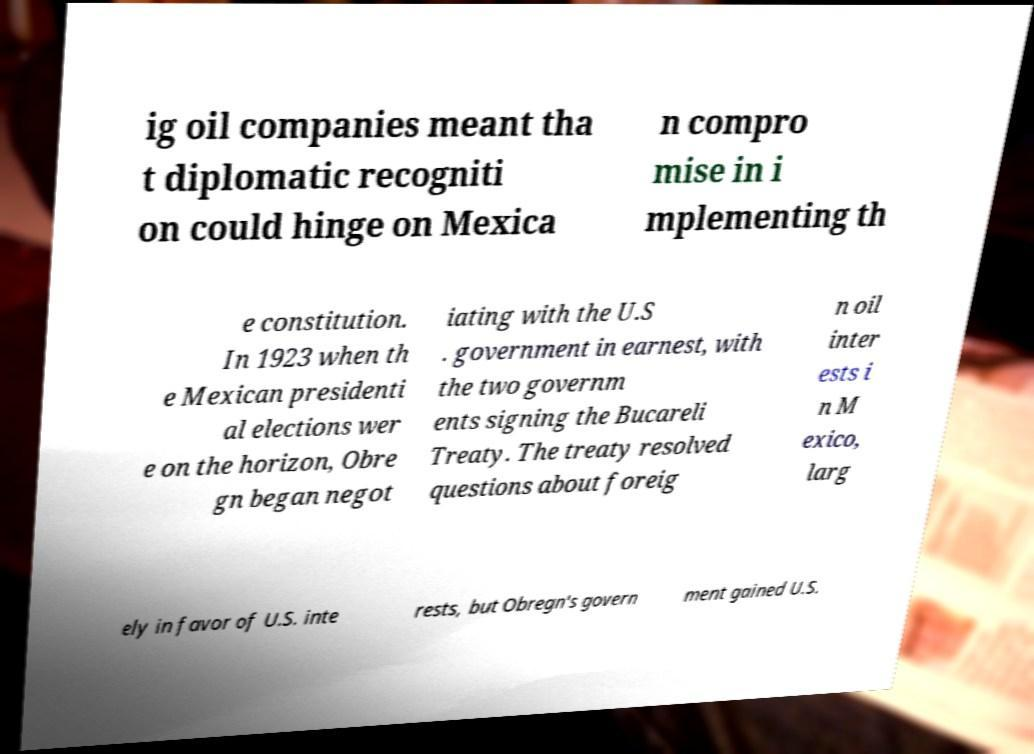Can you accurately transcribe the text from the provided image for me? ig oil companies meant tha t diplomatic recogniti on could hinge on Mexica n compro mise in i mplementing th e constitution. In 1923 when th e Mexican presidenti al elections wer e on the horizon, Obre gn began negot iating with the U.S . government in earnest, with the two governm ents signing the Bucareli Treaty. The treaty resolved questions about foreig n oil inter ests i n M exico, larg ely in favor of U.S. inte rests, but Obregn's govern ment gained U.S. 